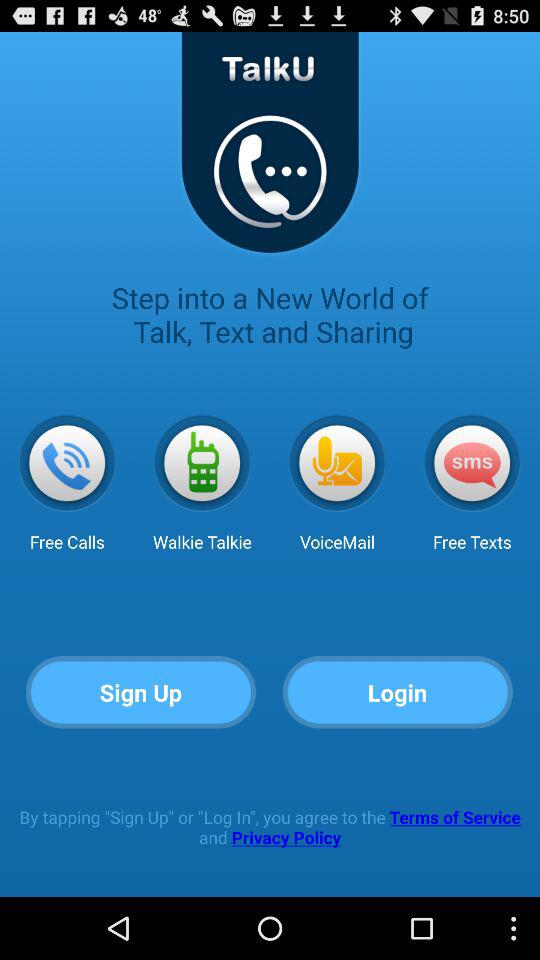What are the different applications that can be used to talk, text, and share? The different applications are: "Free Calls", "Walkie Talkie", "VoiceMail", and "Free Texts". 